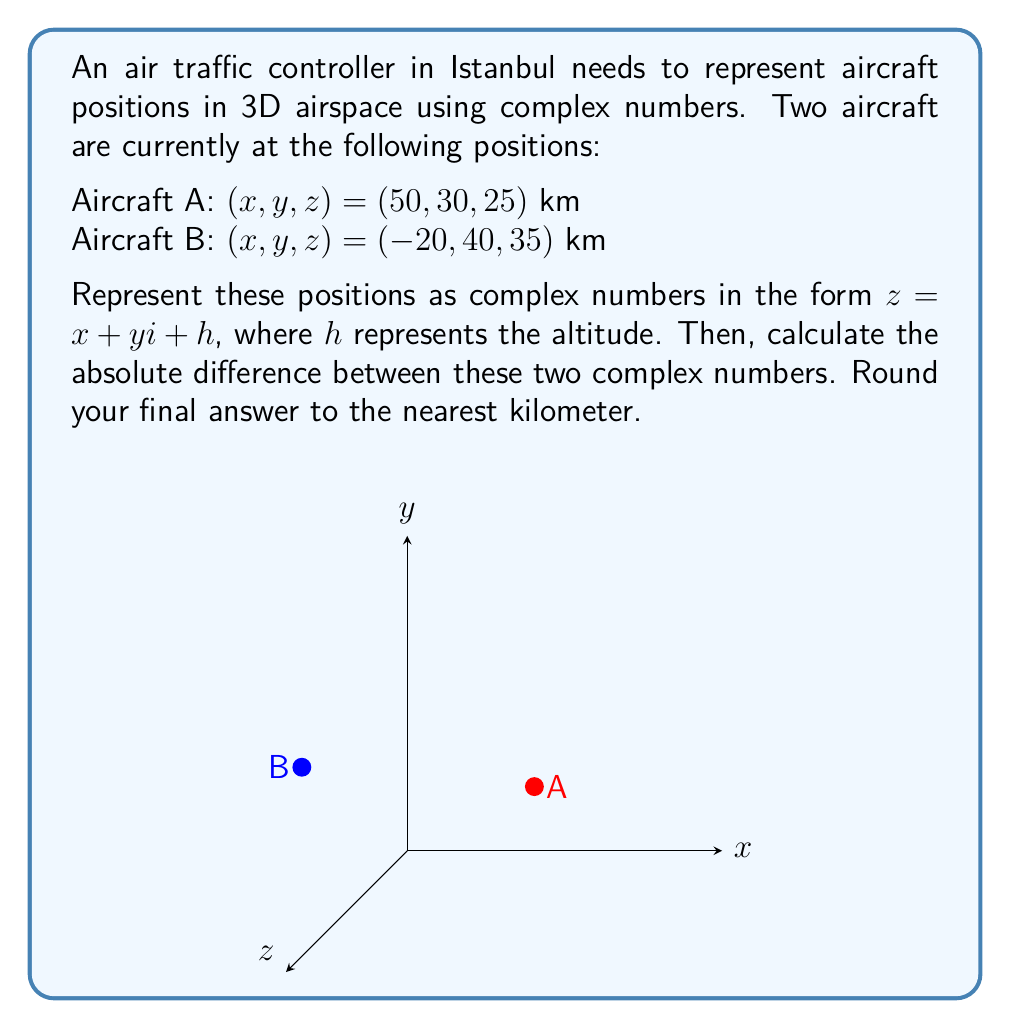Could you help me with this problem? Let's approach this step-by-step:

1) First, we need to represent each aircraft's position as a complex number:

   Aircraft A: $z_A = 50 + 30i + 25$
   Aircraft B: $z_B = -20 + 40i + 35$

2) To find the absolute difference, we need to subtract these complex numbers and then find the magnitude of the result:

   $z_{diff} = z_A - z_B = (50 + 30i + 25) - (-20 + 40i + 35)$

3) Simplifying:
   
   $z_{diff} = (50 - (-20)) + (30 - 40)i + (25 - 35)$
   $z_{diff} = 70 - 10i - 10$
   $z_{diff} = 70 - 10i - 10$

4) Now we need to find the magnitude of this complex number. The magnitude of a complex number $a + bi + c$ is given by $\sqrt{a^2 + b^2 + c^2}$:

   $|z_{diff}| = \sqrt{70^2 + (-10)^2 + (-10)^2}$

5) Calculating:

   $|z_{diff}| = \sqrt{4900 + 100 + 100}$
   $|z_{diff}| = \sqrt{5100}$
   $|z_{diff}| \approx 71.41$ km

6) Rounding to the nearest kilometer:

   $|z_{diff}| \approx 71$ km
Answer: 71 km 